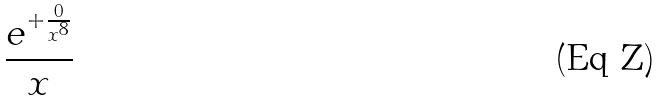Convert formula to latex. <formula><loc_0><loc_0><loc_500><loc_500>\frac { e ^ { + \frac { 0 } { x ^ { 8 } } } } { x }</formula> 